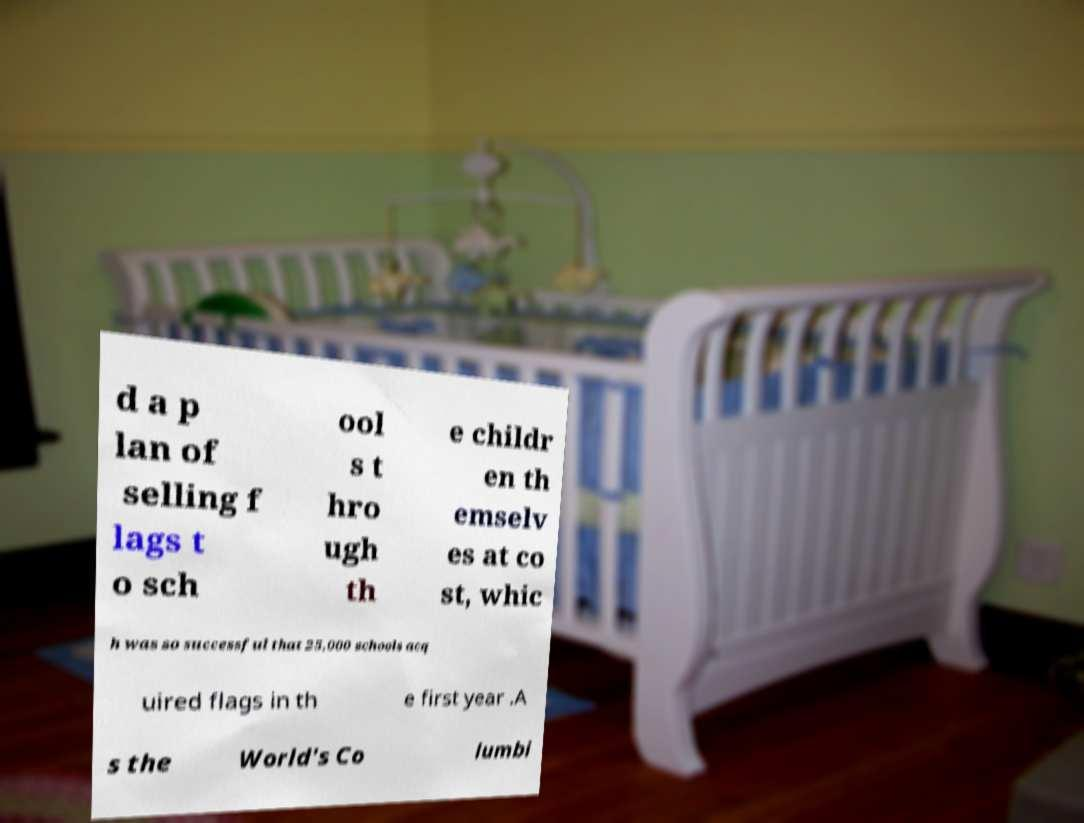Can you accurately transcribe the text from the provided image for me? d a p lan of selling f lags t o sch ool s t hro ugh th e childr en th emselv es at co st, whic h was so successful that 25,000 schools acq uired flags in th e first year .A s the World's Co lumbi 